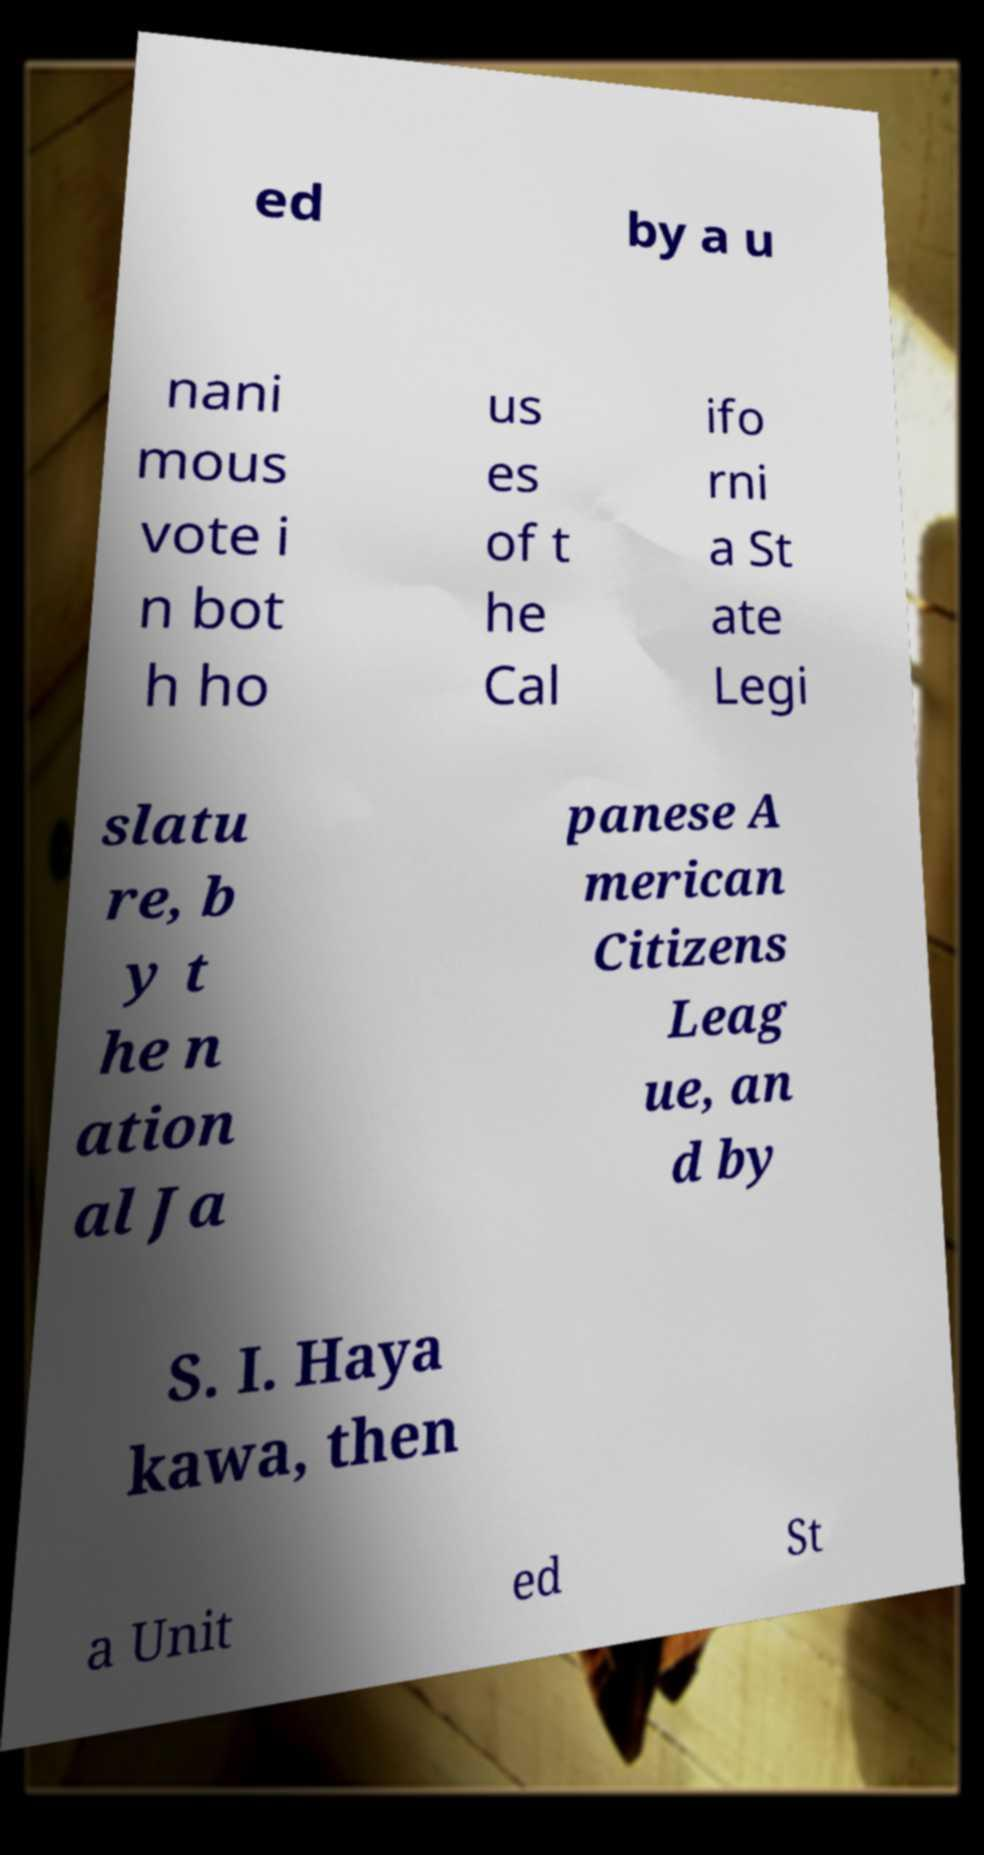Could you extract and type out the text from this image? ed by a u nani mous vote i n bot h ho us es of t he Cal ifo rni a St ate Legi slatu re, b y t he n ation al Ja panese A merican Citizens Leag ue, an d by S. I. Haya kawa, then a Unit ed St 